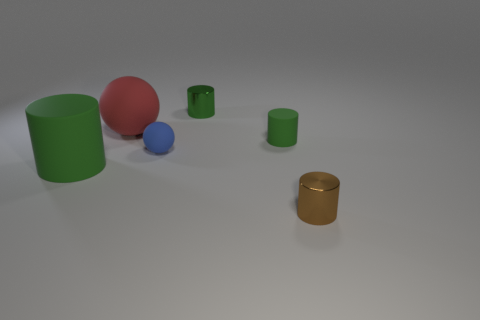How many green cylinders must be subtracted to get 1 green cylinders? 2 Subtract all red cubes. How many green cylinders are left? 3 Subtract all purple cylinders. Subtract all green cubes. How many cylinders are left? 4 Add 1 big matte blocks. How many objects exist? 7 Subtract all cylinders. How many objects are left? 2 Add 5 large red rubber objects. How many large red rubber objects are left? 6 Add 5 green matte objects. How many green matte objects exist? 7 Subtract 0 yellow cylinders. How many objects are left? 6 Subtract all large rubber objects. Subtract all small rubber balls. How many objects are left? 3 